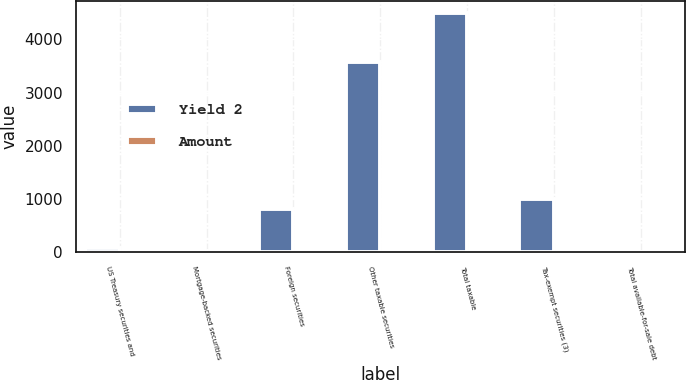<chart> <loc_0><loc_0><loc_500><loc_500><stacked_bar_chart><ecel><fcel>US Treasury securities and<fcel>Mortgage-backed securities<fcel>Foreign securities<fcel>Other taxable securities<fcel>Total taxable<fcel>Tax-exempt securities (3)<fcel>Total available-for-sale debt<nl><fcel>Yield 2<fcel>78<fcel>17<fcel>819<fcel>3581<fcel>4495<fcel>1000<fcel>5.82<nl><fcel>Amount<fcel>4.08<fcel>5.59<fcel>4.88<fcel>4.7<fcel>4.73<fcel>5.82<fcel>4.93<nl></chart> 